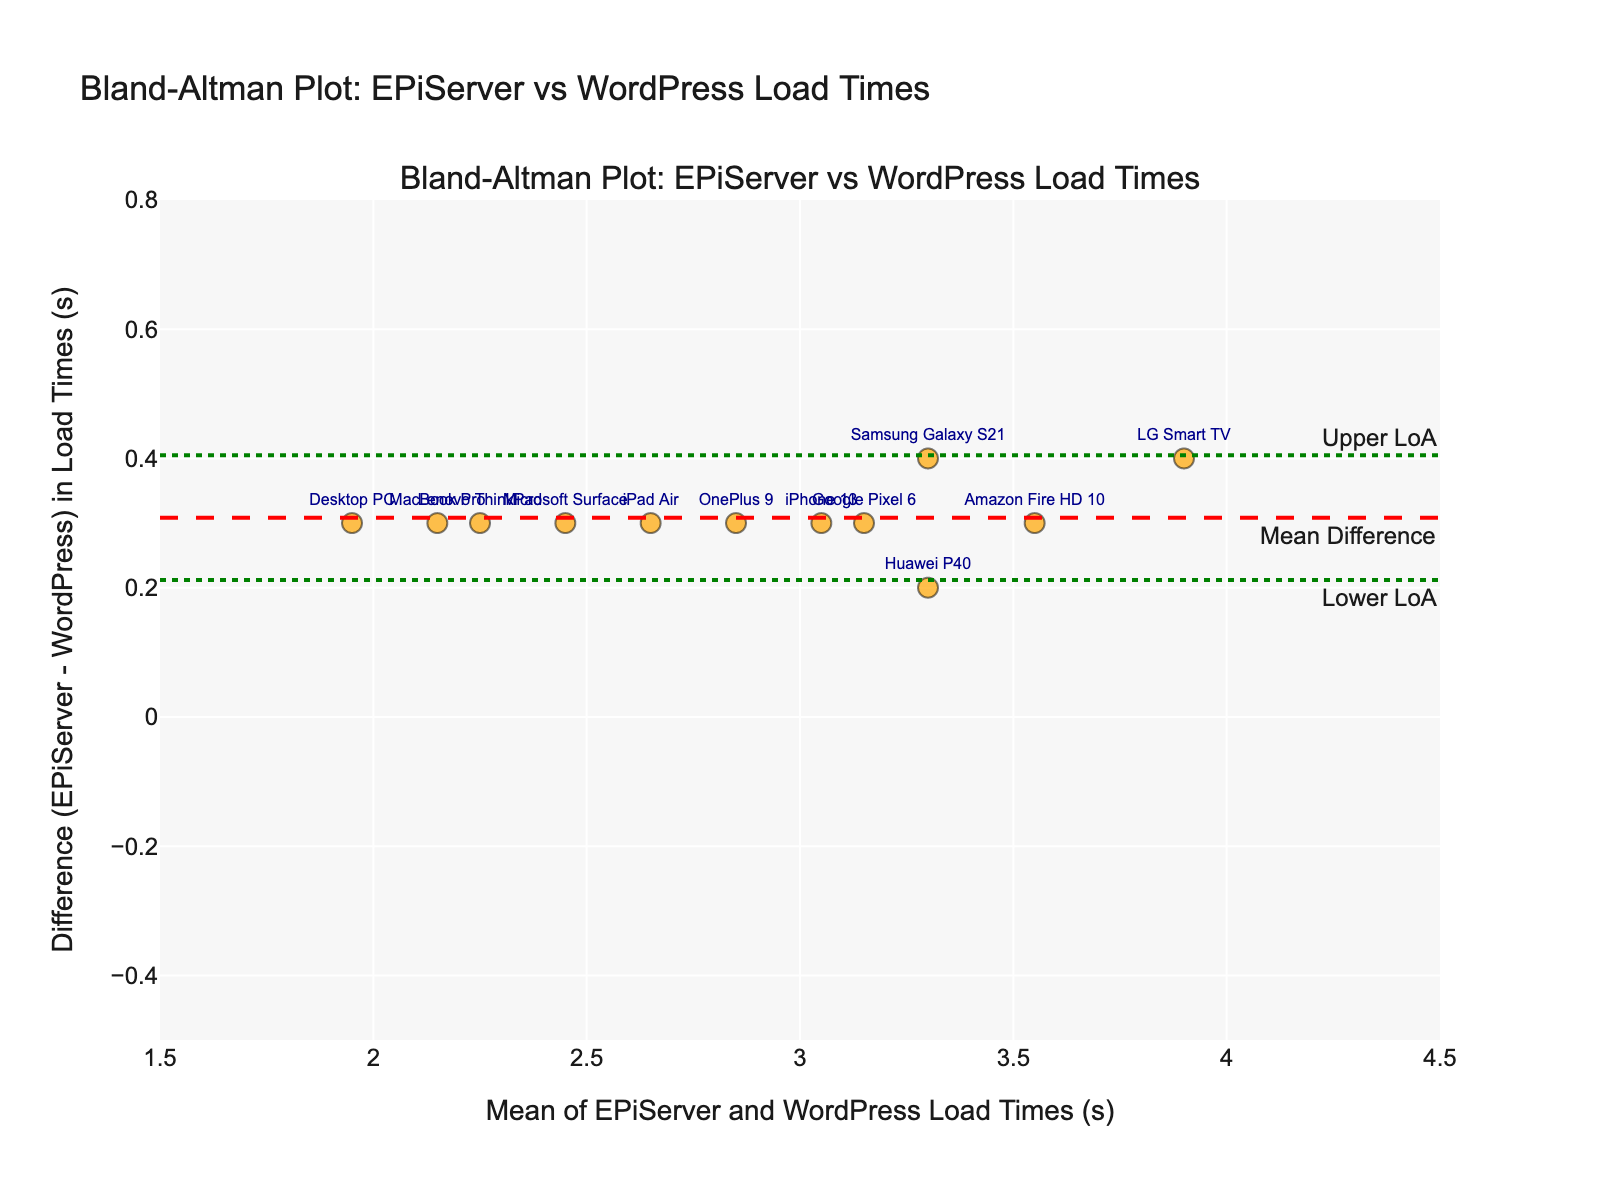What's the title of the figure? The title is usually displayed at the top of the figure. By looking at this location, we can see the name of the title.
Answer: Bland-Altman Plot: EPiServer vs WordPress Load Times How many data points are represented in the plot? By counting the number of markers on the plot, we can determine the number of data points.
Answer: 12 What is the x-axis label of the figure? The label for the x-axis is typically displayed below the axis. By looking there, we see the label.
Answer: Mean of EPiServer and WordPress Load Times (s) What does the red dashed line on the figure represent? The red dashed line is usually annotated, and the text here indicates what it signifies.
Answer: Mean Difference Which device has the largest difference in load times between EPiServer and WordPress? By looking at the data points on the figure and identifying the one furthest from the y=0 line, we can find the device with the largest difference. Each point is labeled with the device name.
Answer: LG Smart TV What are the approximate values for the Upper and Lower Limits of Agreement? The upper and lower limits of agreement are represented by green dotted lines, often annotated. By reading these annotations, we can get their values.
Answer: Upper LoA: ~0.65, Lower LoA: ~-0.45 Describe the overall trend observed in the Bland-Altman plot. The trend can be understood by observing the scatter plot. Most points are above the x-axis, indicating that EPiServer generally has higher load times compared to WordPress.
Answer: EPiServer generally has higher load times compared to WordPress Which two devices have the smallest difference in load times? By looking for the points closest to the y=0 line and reading their labels, we can identify the devices.
Answer: Huawei P40 and OnePlus 9 What is the approximate mean difference between EPiServer and WordPress load times across all devices? The mean difference line is typically labeled and annotated right on the plot. By reading this annotation, we get the approximate value.
Answer: ~0.3 Compare the load times for the 'iPhone 13' and 'Samsung Galaxy S21'. Which device shows a larger load time difference? By identifying the points labeled 'iPhone 13' and 'Samsung Galaxy S21', we can compare their vertical distance from the y=0 line to see which has a larger difference.
Answer: Samsung Galaxy S21 